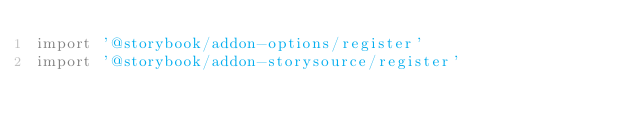Convert code to text. <code><loc_0><loc_0><loc_500><loc_500><_JavaScript_>import '@storybook/addon-options/register'
import '@storybook/addon-storysource/register'
</code> 